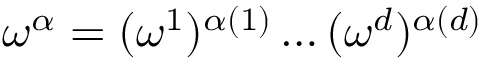<formula> <loc_0><loc_0><loc_500><loc_500>\omega ^ { \alpha } = ( \omega ^ { 1 } ) ^ { \alpha ( 1 ) } \dots ( \omega ^ { d } ) ^ { \alpha ( d ) }</formula> 